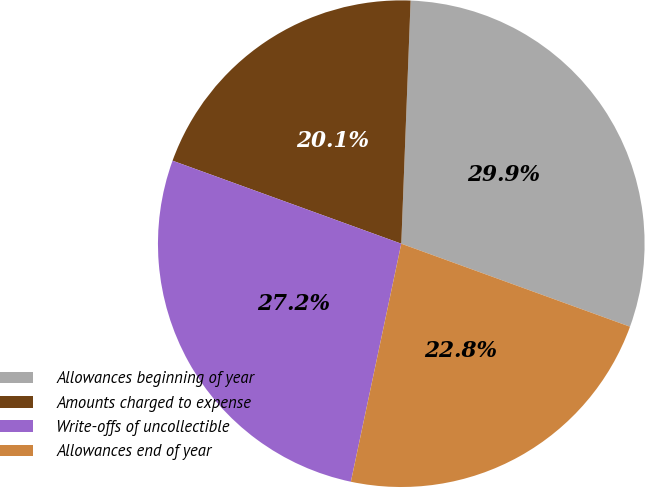<chart> <loc_0><loc_0><loc_500><loc_500><pie_chart><fcel>Allowances beginning of year<fcel>Amounts charged to expense<fcel>Write-offs of uncollectible<fcel>Allowances end of year<nl><fcel>29.93%<fcel>20.07%<fcel>27.22%<fcel>22.78%<nl></chart> 